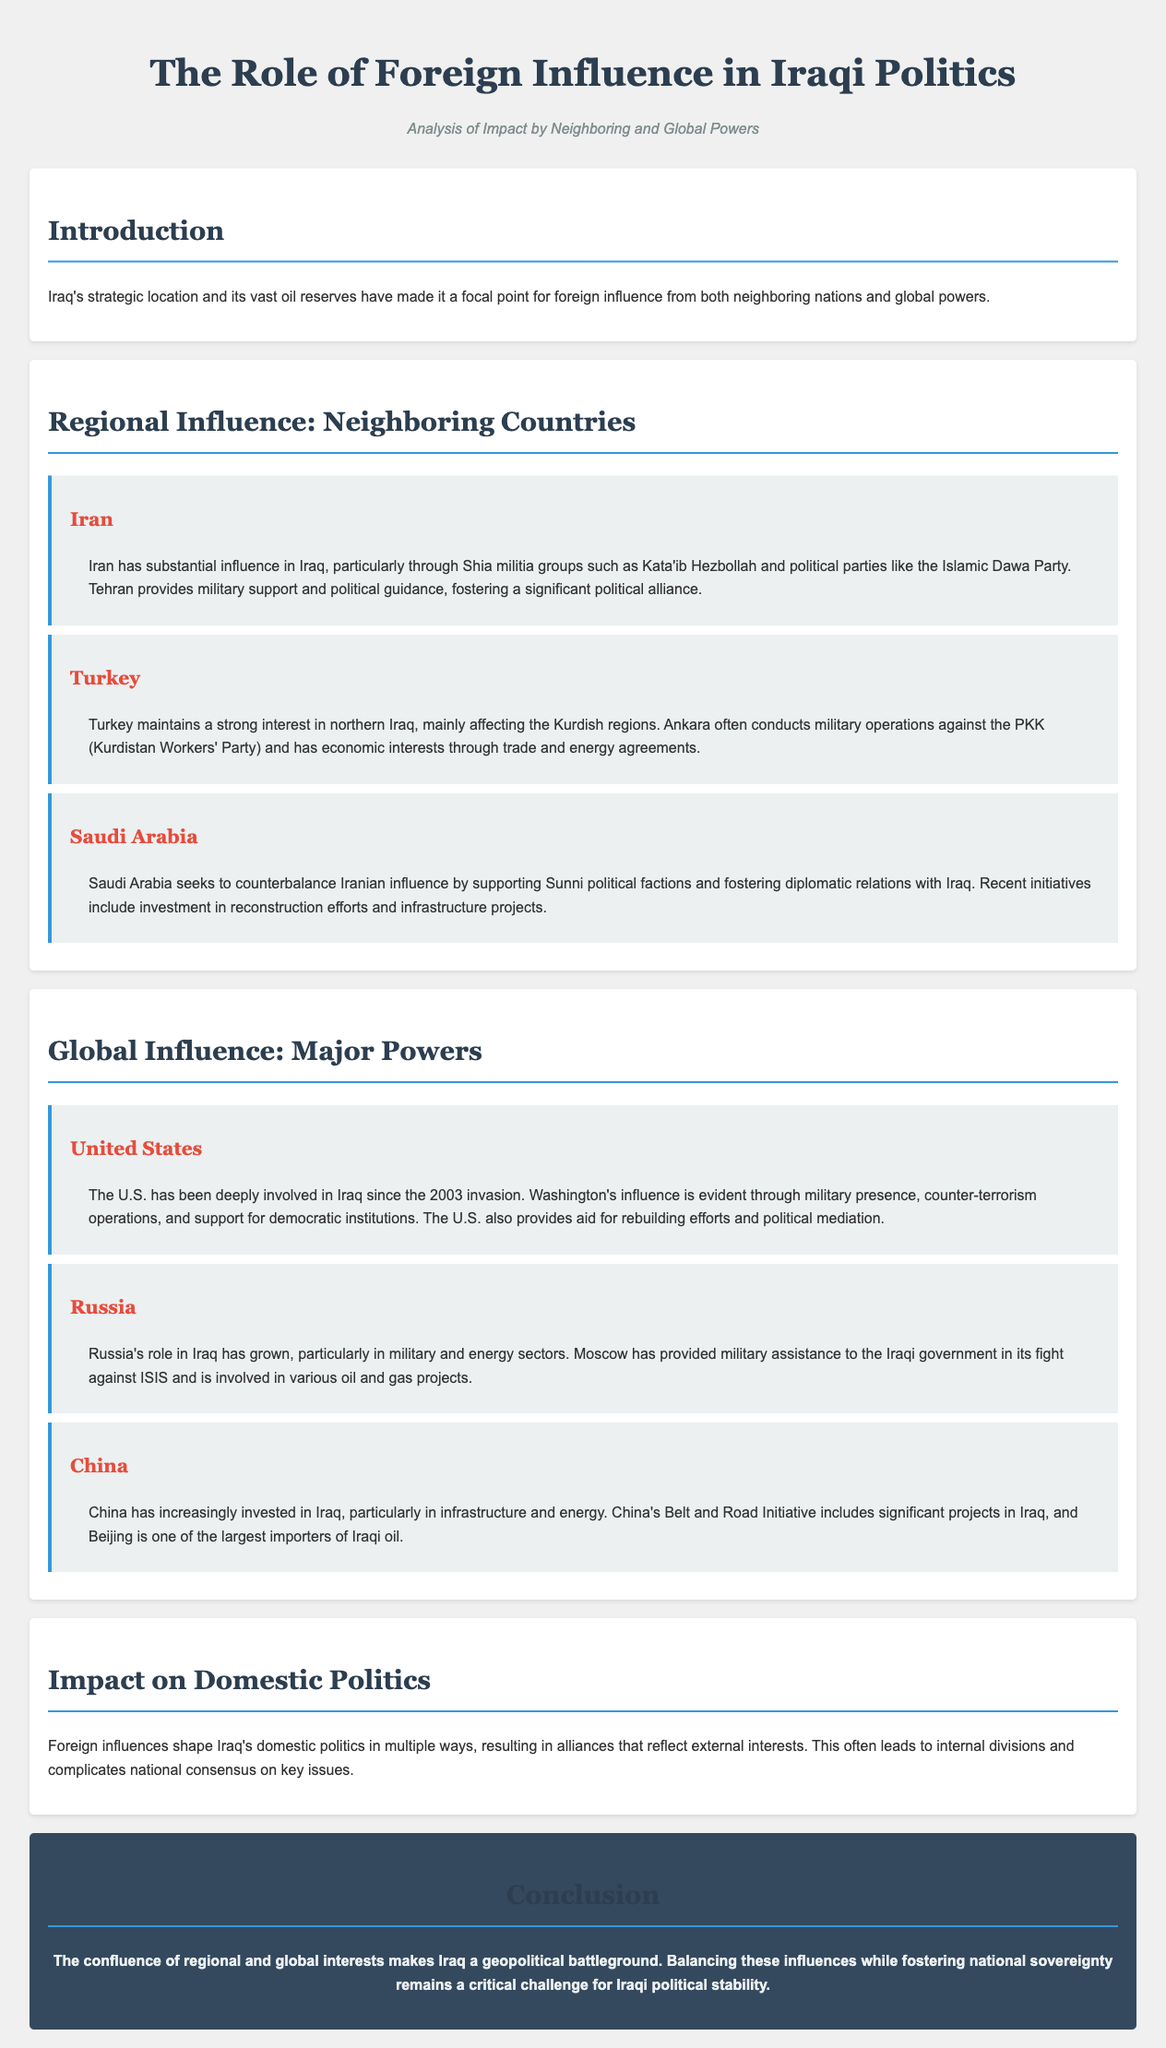What is the primary focus of foreign influence in Iraq? The document states that Iraq's strategic location and oil reserves make it a focal point for foreign influence.
Answer: Foreign influence Which country provides military support to Iraqi Shia militia groups? The document indicates that Iran provides military support and political guidance to Shia militia groups in Iraq.
Answer: Iran What major power has been involved in Iraq since the 2003 invasion? According to the document, the U.S. has been deeply involved in Iraq since the 2003 invasion.
Answer: United States Which country seeks to counterbalance Iranian influence? The document mentions that Saudi Arabia seeks to counterbalance Iranian influence by supporting Sunni political factions.
Answer: Saudi Arabia What initiative includes significant projects in Iraq by China? The Belt and Road Initiative is mentioned as including significant projects in Iraq.
Answer: Belt and Road Initiative How does foreign influence affect Iraqi domestic politics? The document states that foreign influences shape Iraq's domestic politics, often leading to internal divisions.
Answer: Internal divisions What is a critical challenge for Iraqi political stability? Balancing regional and global influences while fostering national sovereignty is noted as a critical challenge.
Answer: Balancing influences Which neighboring country conducts military operations against the PKK? The document states that Turkey conducts military operations against the PKK in northern Iraq.
Answer: Turkey 